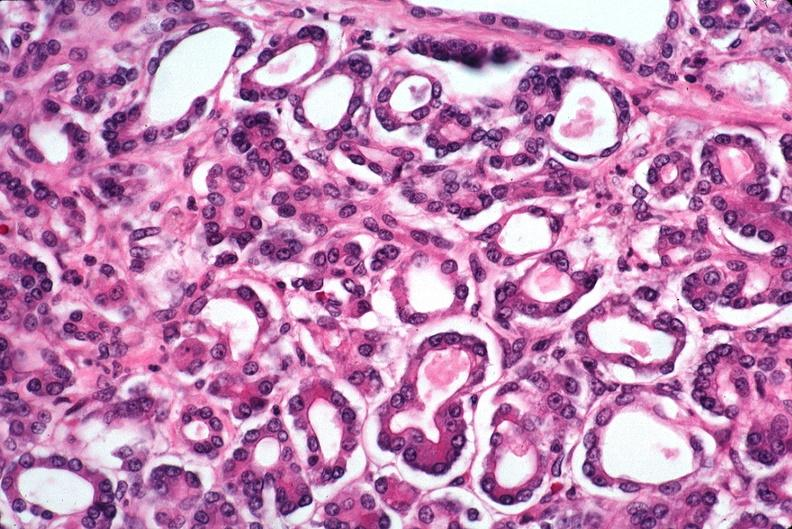what does this image show?
Answer the question using a single word or phrase. Pancreas 